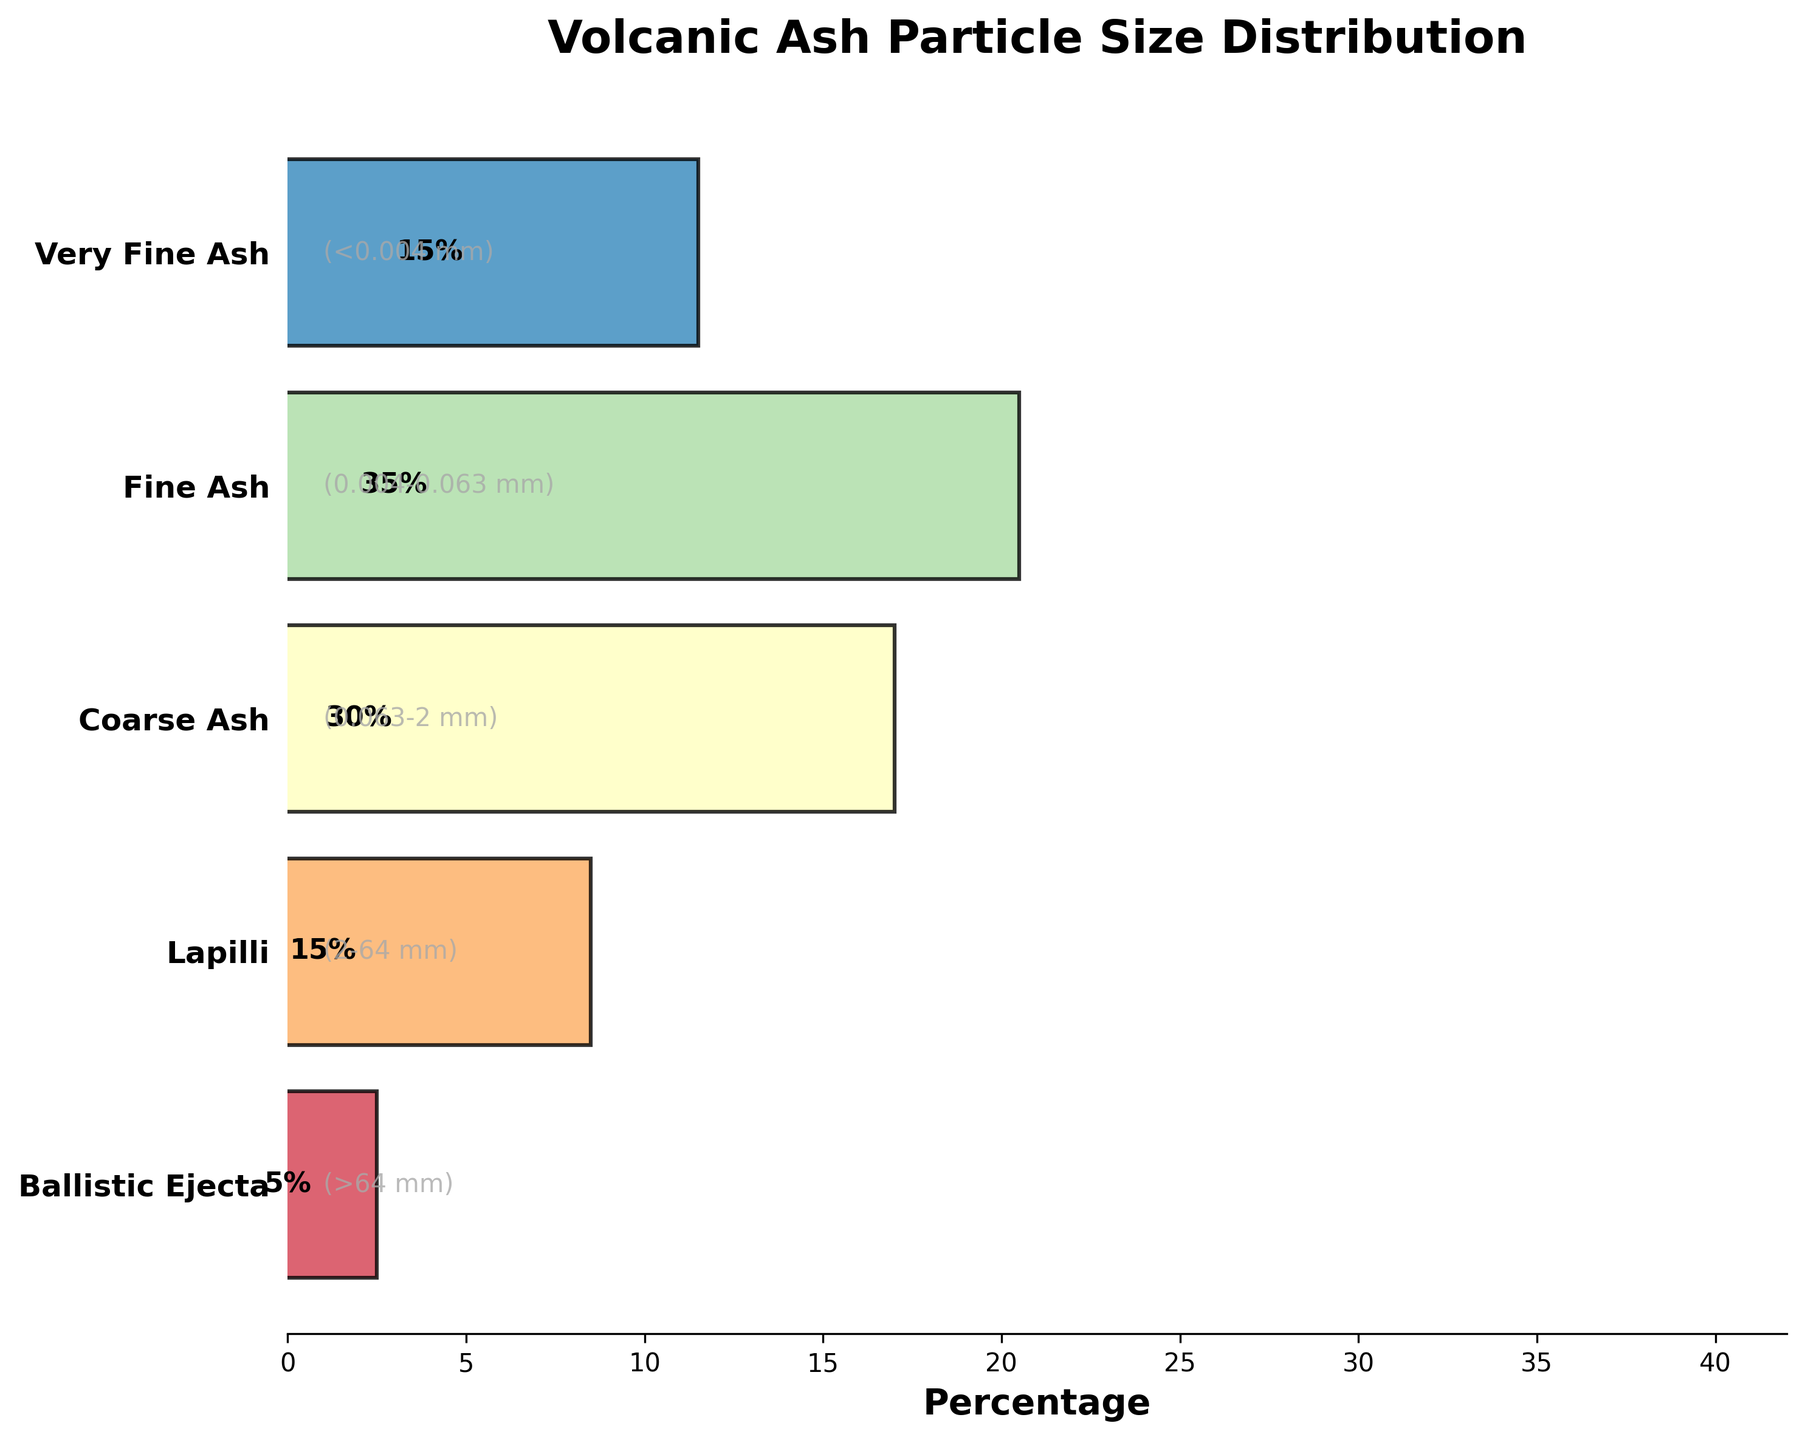What's the title of the figure? Look at the top of the figure where the title is placed. The title clearly states what the figure represents, which is often written in bold and large font.
Answer: Volcanic Ash Particle Size Distribution Which particle size has the highest percentage? Examine the width of each part of the funnel. The widest section indicates the highest percentage of particle size distribution.
Answer: Fine Ash What is the percentage of Very Fine Ash particles? Locate the label 'Very Fine Ash' on the y-axis and then read the percentage displayed within its section.
Answer: 15% How many different stages of particle sizes are represented in the figure? Count the number of unique stages listed on the y-axis. Each one corresponds to a different category of particle size.
Answer: 5 Which particle size has the smallest percentage? Identify the narrowest section of the funnel. The narrowest section indicates the smallest percentage.
Answer: Ballistic Ejecta What is the percentage difference between Coarse Ash and Fine Ash? Find the percentage for Coarse Ash (30%) and Fine Ash (35%), then subtract the smaller percentage from the larger one to find the difference: 35% - 30% = 5%.
Answer: 5% What is the combined percentage of Lapilli and Very Fine Ash? Add the percentages of Lapilli (15%) and Very Fine Ash (15%) to get their combined total: 15% + 15% = 30%.
Answer: 30% Which particle sizes share the same percentage? Compare the percentages listed for each particle size. Identify any two stages with identical values.
Answer: Lapilli and Very Fine Ash Approximately what proportion of the particles is smaller than 0.063 mm (combining Fine Ash and Very Fine Ash)? Add the percentages for Fine Ash (35%) and Very Fine Ash (15%) to get the combined proportion: 35% + 15% = 50%.
Answer: 50% Is the percentage of the largest particle size greater or smaller than the combined percentage of the smallest particle sizes? Compare the percentage of Ballistic Ejecta (5%) with the total percentage of Fine Ash (35%) and Very Fine Ash (15%). Combined total for smallest particles is: 35% + 15% = 50%. 5% is smaller than 50%.
Answer: Smaller 